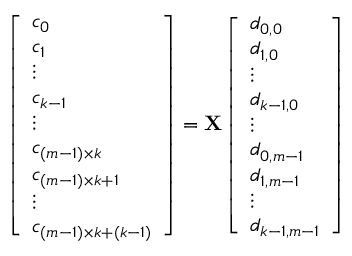Convert formula to latex. <formula><loc_0><loc_0><loc_500><loc_500>\begin{array} { r } { \left [ \begin{array} { l } { c _ { 0 } } \\ { c _ { 1 } } \\ { \vdots } \\ { c _ { k - 1 } } \\ { \vdots } \\ { c _ { ( m - 1 ) \times k } } \\ { c _ { ( m - 1 ) \times k + 1 } } \\ { \vdots } \\ { c _ { ( m - 1 ) \times k + ( k - 1 ) } } \end{array} \right ] = { X } \left [ \begin{array} { l } { d _ { 0 , 0 } } \\ { d _ { 1 , 0 } } \\ { \vdots } \\ { d _ { k - 1 , 0 } } \\ { \vdots } \\ { d _ { 0 , m - 1 } } \\ { d _ { 1 , m - 1 } } \\ { \vdots } \\ { d _ { k - 1 , m - 1 } } \end{array} \right ] } \end{array}</formula> 